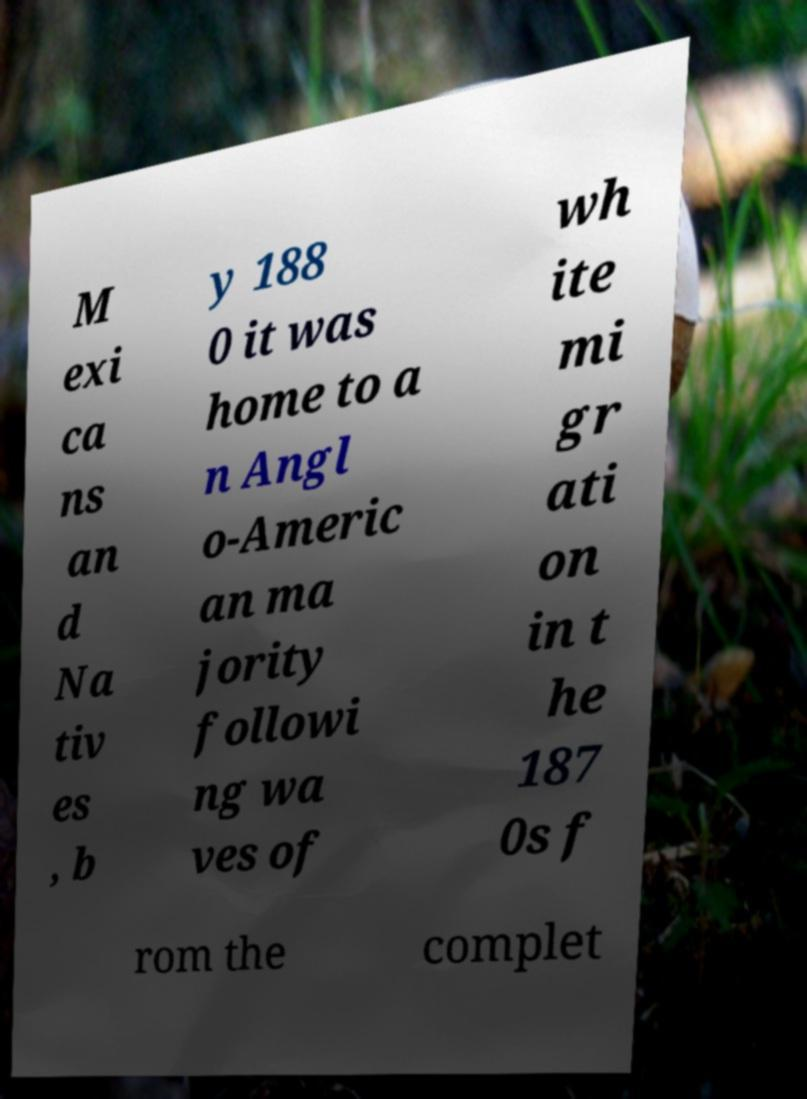I need the written content from this picture converted into text. Can you do that? M exi ca ns an d Na tiv es , b y 188 0 it was home to a n Angl o-Americ an ma jority followi ng wa ves of wh ite mi gr ati on in t he 187 0s f rom the complet 